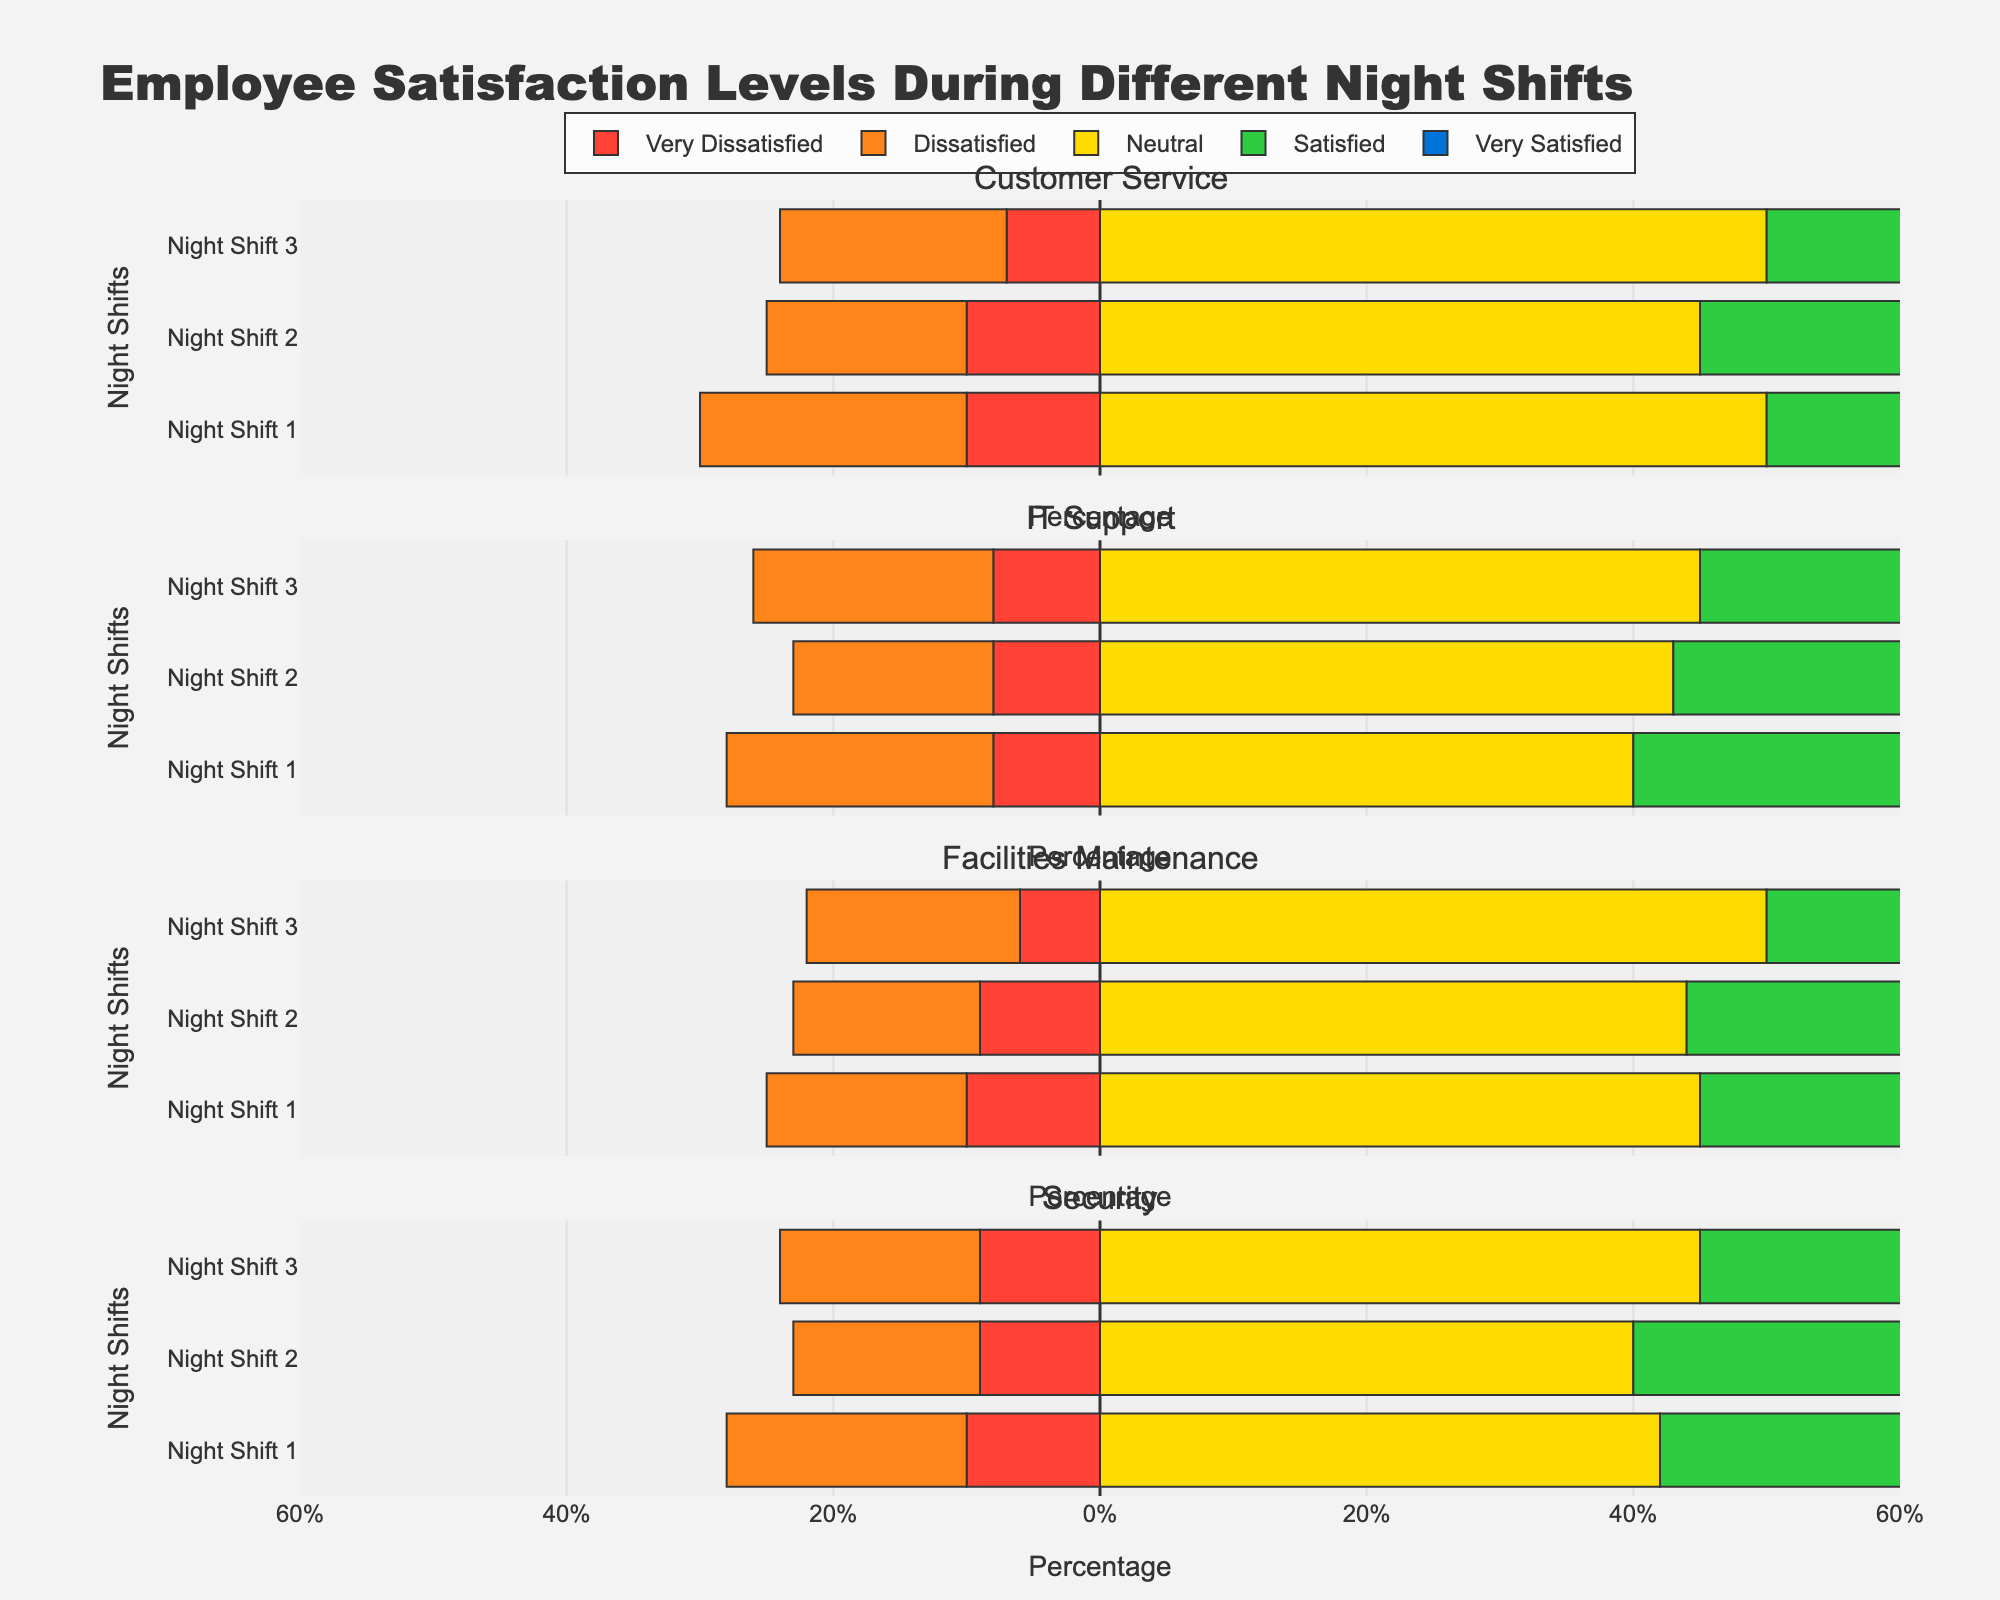How does employee satisfaction in Night Shift 1 for the Customer Service department compare to Night Shift 2 in the same department? On Night Shift 1 in the Customer Service department, there are 5 Very Satisfied and 15 Satisfied, making a total of 20 satisfied employees. For Night Shift 2, there are 10 Very Satisfied and 20 Satisfied, making a total of 30 satisfied employees. Therefore, Night Shift 2 has more satisfied employees than Night Shift 1.
Answer: Night Shift 2 has more satisfied employees Which night shift has the highest number of Very Satisfied employees in the IT Support department? In the IT Support department, Night Shift 1 has 7 Very Satisfied, Night Shift 2 has 12 Very Satisfied, and Night Shift 3 has 9 Very Satisfied. Comparing these values, Night Shift 2 has the highest number of Very Satisfied employees.
Answer: Night Shift 2 Are there more Neutral or Dissatisfied employees in Facilities Maintenance during Night Shift 3? In Facilities Maintenance during Night Shift 3, there are 50 Neutral employees and 16 Dissatisfied employees. Since 50 is greater than 16, there are more Neutral employees.
Answer: More Neutral employees Which department has the highest percentage of Very Dissatisfied employees during Night Shift 1? For Night Shift 1, Customer Service has 10 Very Dissatisfied out of 100 total (10%), IT Support has 8 out of 100 (8%), Facilities Maintenance has 10 out of 100 (10%), and Security has 10 out of 100 (10%). Customer Service, Facilities Maintenance, and Security all tie with the highest percentage at 10%.
Answer: Customer Service, Facilities Maintenance, and Security What is the total number of dissatisfied employees (Dissatisfied + Very Dissatisfied) in Security across all night shifts? For Night Shift 1 in Security, there are 18 Dissatisfied and 10 Very Dissatisfied (28 total). For Night Shift 2, there are 14 Dissatisfied and 9 Very Dissatisfied (23 total). For Night Shift 3, there are 15 Dissatisfied and 9 Very Dissatisfied (24 total). Adding these, 28 + 23 + 24 = 75 dissatisfied employees.
Answer: 75 How does the number of Neutral employees in Night Shift 2 for IT Support compare to Night Shift 2 for Facilities Maintenance? In Night Shift 2, IT Support has 43 Neutral employees and Facilities Maintenance has 44 Neutral employees. Comparing these values, Facilities Maintenance has 1 more Neutral employee than IT Support.
Answer: Facilities Maintenance has 1 more Neutral employee In Customer Service during Night Shift 3, what percentage of employees are either Satisfied or Very Satisfied? In Night Shift 3 for Customer Service, there are 8 Very Satisfied and 18 Satisfied employees, a total of 26 satisfied employees. There are 100 employees in total. The percentage is (26/100) * 100 = 26%.
Answer: 26% Which department showed the most consistent (least variation) number of Very Dissatisfied employees across all night shifts? Customer Service has counts of 10, 10, and 7. IT Support has counts of 8, 8, and 8. Facilities Maintenance has counts of 10, 9, and 6. Security has counts of 10, 9, and 9. IT Support shows consistent counts across all night shifts with all values being 8.
Answer: IT Support In which Night Shift for Facilities Maintenance is the highest number of satisfied employees (Satisfied + Very Satisfied)? Adding Very Satisfied and Satisfied employees for Facilities Maintenance: Night Shift 1 has 30 (10+20), Night Shift 2 has 33 (11+22), and Night Shift 3 has 28 (10+18). Night Shift 2 has the highest number of satisfied employees.
Answer: Night Shift 2 In the Security department, which Night Shift has the lowest number of Dissatisfied employees? In the Security department, Night Shift 1 has 18 Dissatisfied employees, Night Shift 2 has 14, and Night Shift 3 has 15. Comparing these values, Night Shift 2 has the lowest number of Dissatisfied employees.
Answer: Night Shift 2 